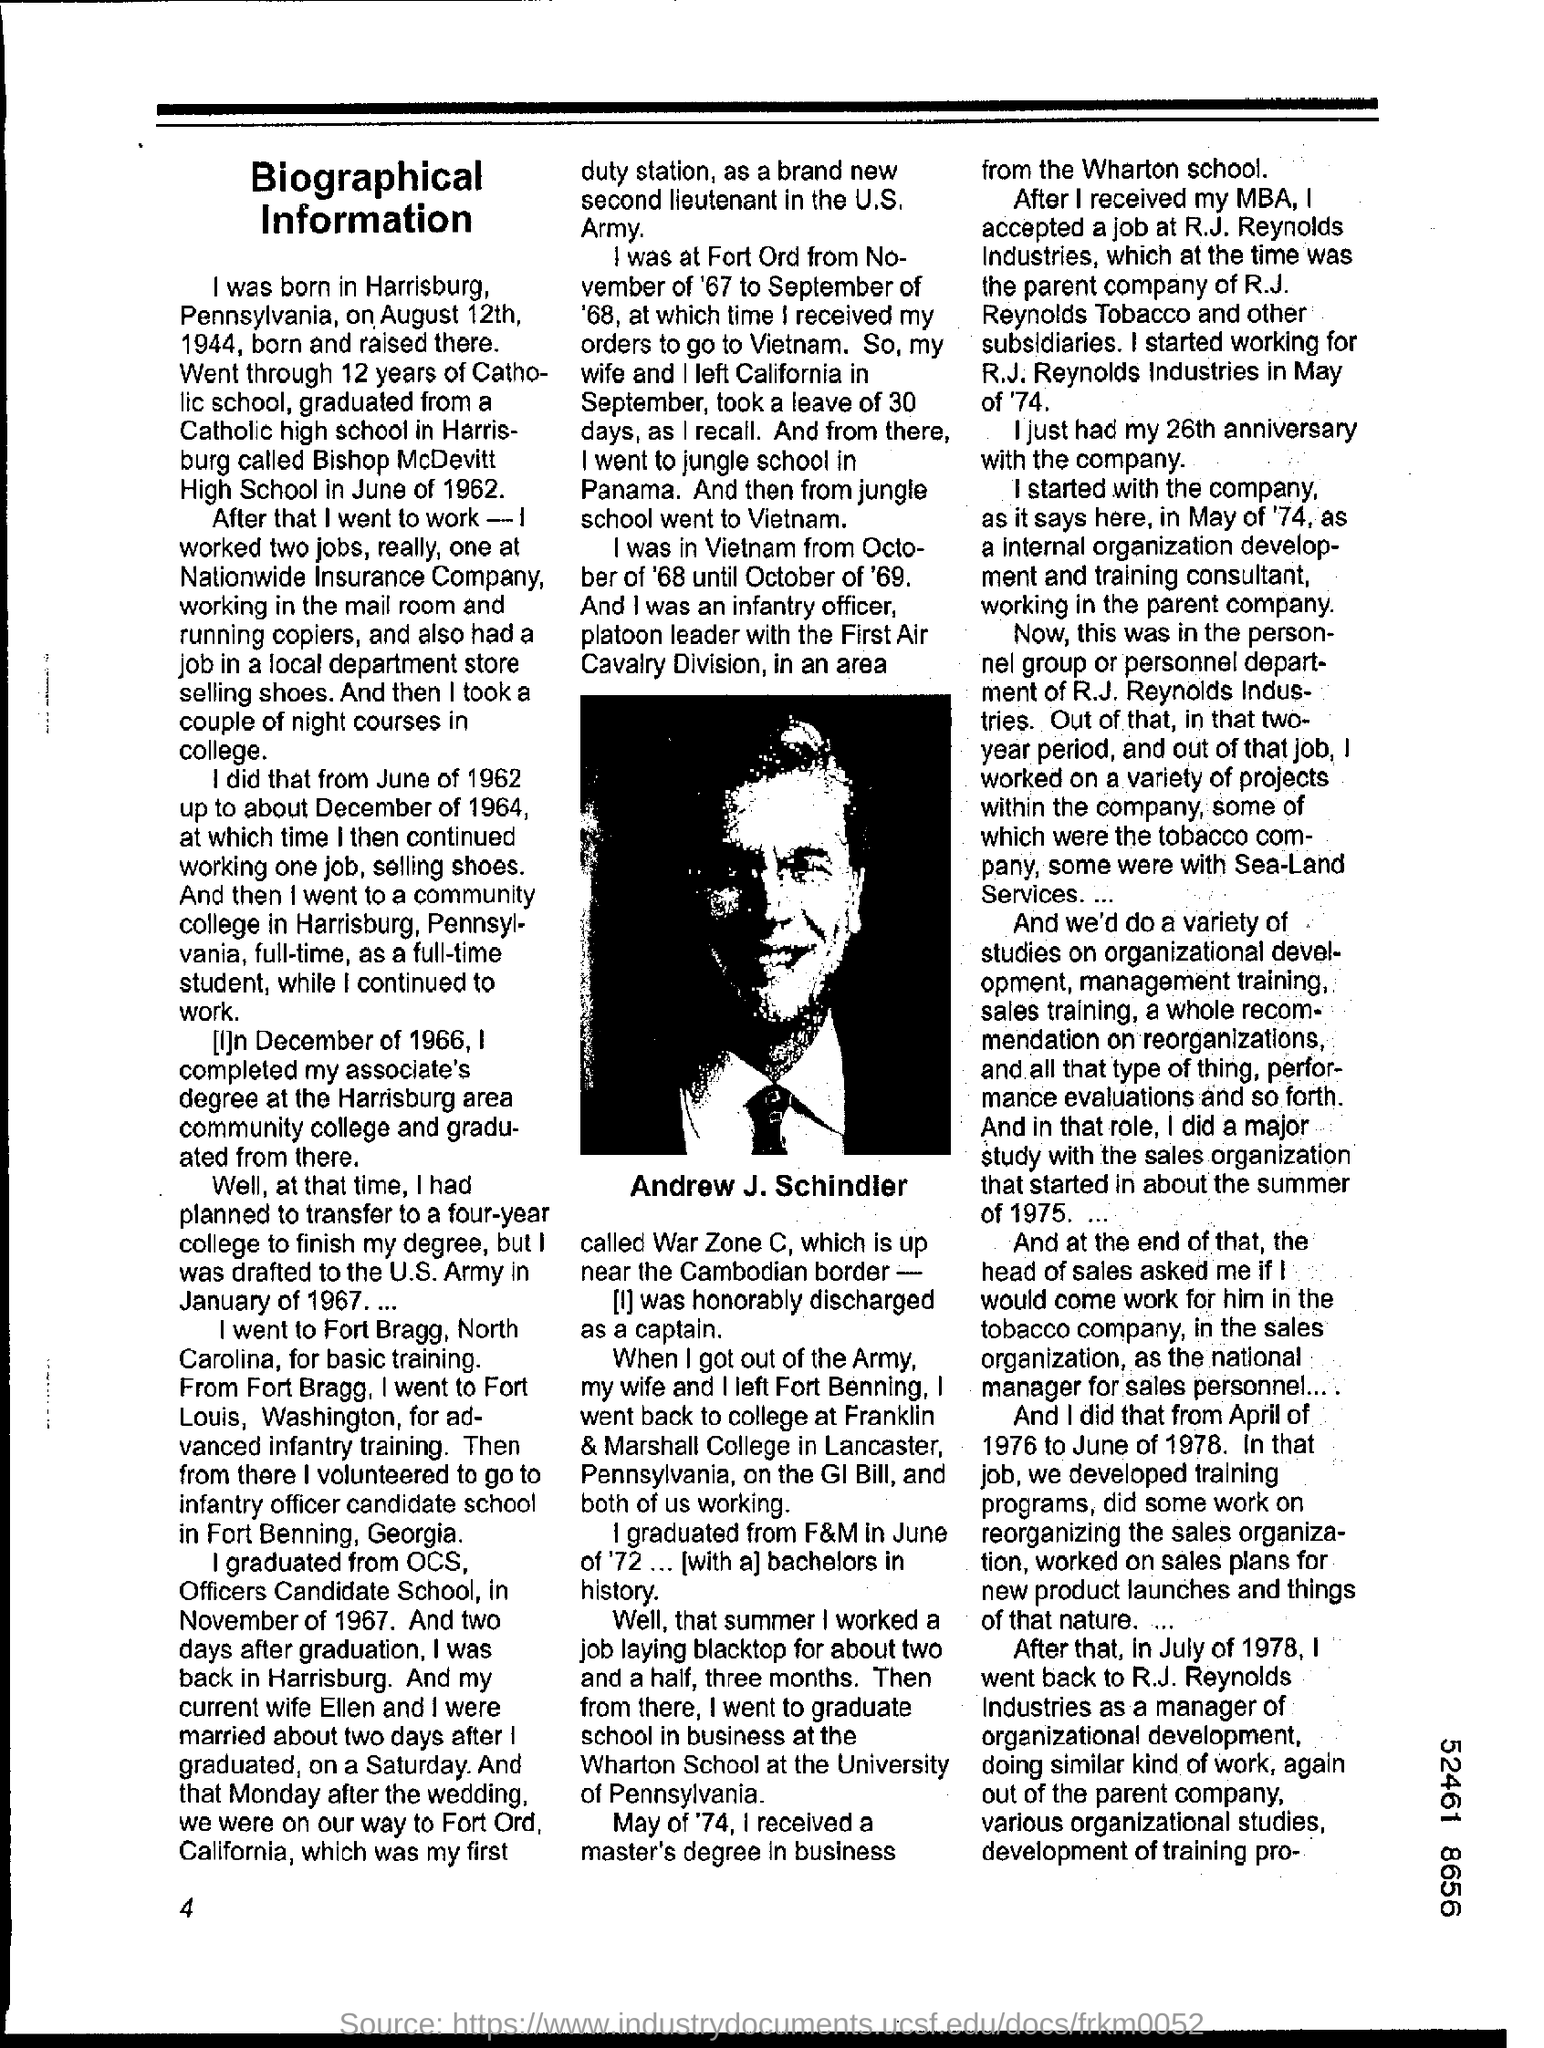Whose picture is shown?
Make the answer very short. Andrew j. schindler. 